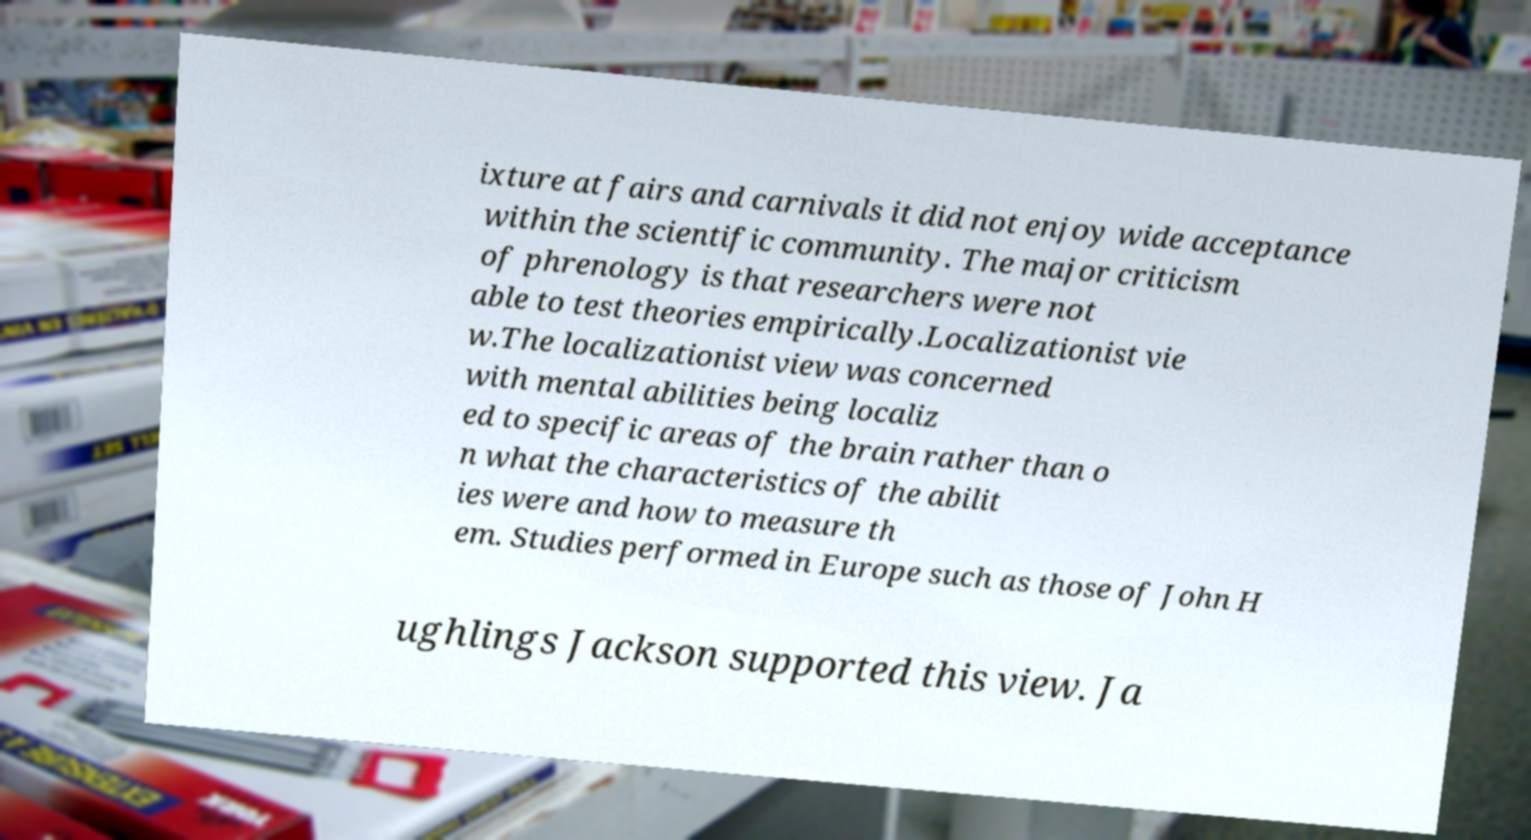What messages or text are displayed in this image? I need them in a readable, typed format. ixture at fairs and carnivals it did not enjoy wide acceptance within the scientific community. The major criticism of phrenology is that researchers were not able to test theories empirically.Localizationist vie w.The localizationist view was concerned with mental abilities being localiz ed to specific areas of the brain rather than o n what the characteristics of the abilit ies were and how to measure th em. Studies performed in Europe such as those of John H ughlings Jackson supported this view. Ja 